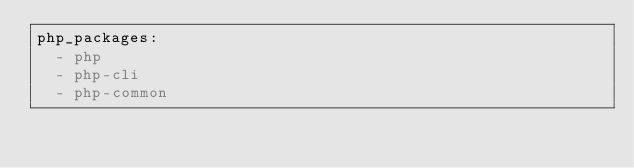Convert code to text. <code><loc_0><loc_0><loc_500><loc_500><_YAML_>php_packages:
  - php
  - php-cli
  - php-common</code> 